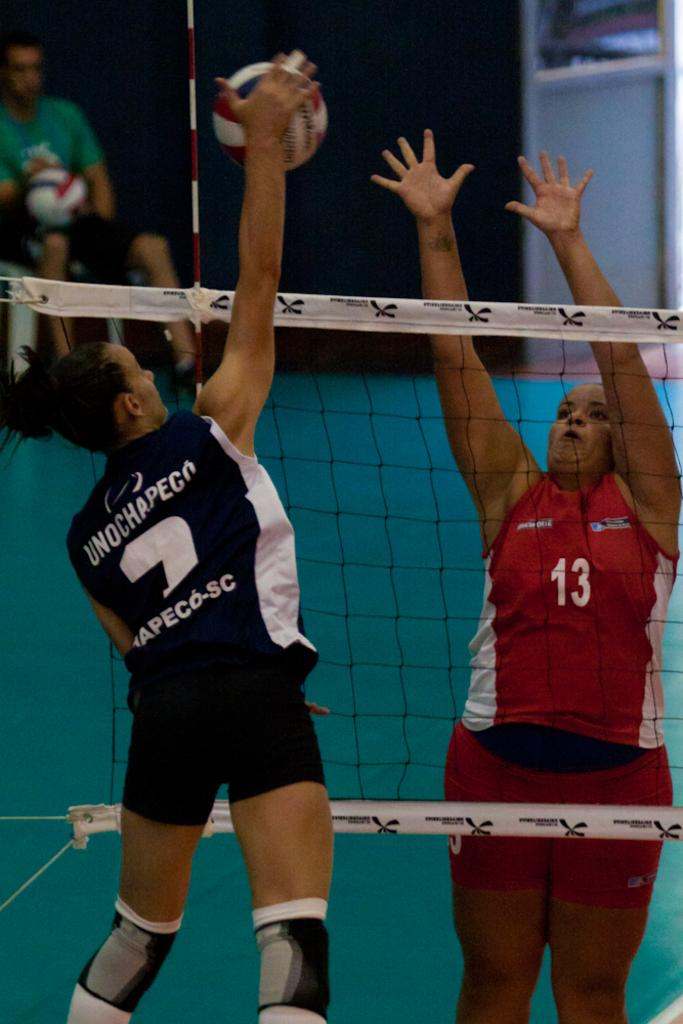How many people are in the image? There are three people in the image. What can be seen in the background of the image? There are objects visible in the background of the image. What is the purpose of the net in the image? The purpose of the net is not specified, but it could be used for various activities like sports or fishing. What type of structures are present in the image? There are walls in the image. What time does the clock in the image show? There is no clock present in the image. How does the wave in the image affect the people? There is no wave present in the image. 